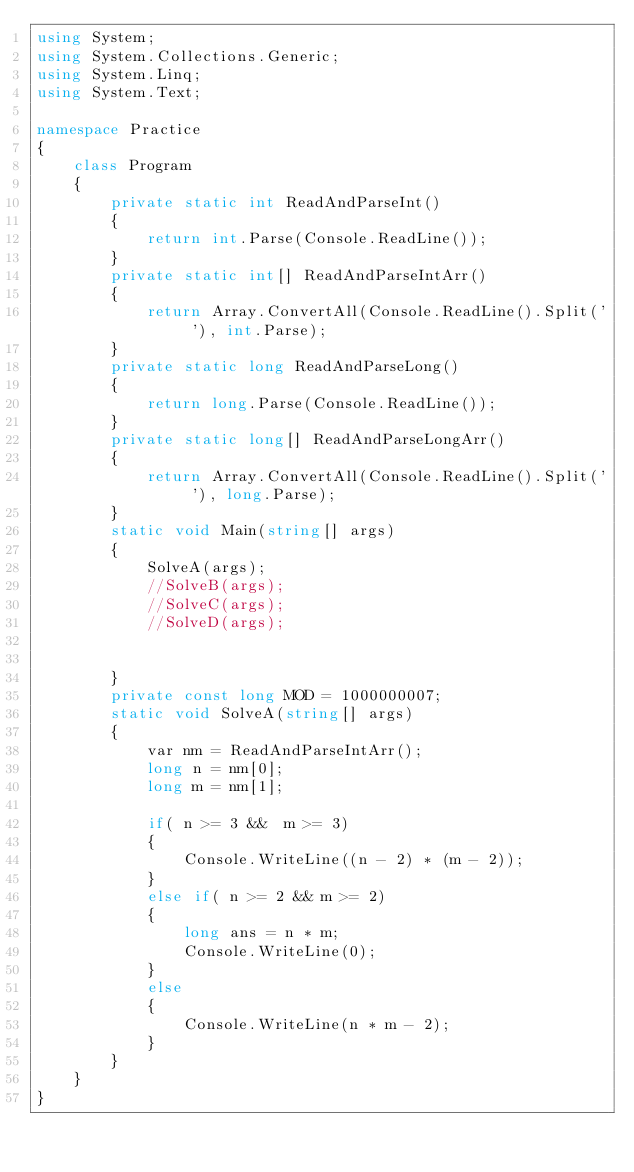<code> <loc_0><loc_0><loc_500><loc_500><_C#_>using System;
using System.Collections.Generic;
using System.Linq;
using System.Text;

namespace Practice
{
    class Program
    {
        private static int ReadAndParseInt()
        {
            return int.Parse(Console.ReadLine());
        }
        private static int[] ReadAndParseIntArr()
        {
            return Array.ConvertAll(Console.ReadLine().Split(' '), int.Parse);
        }
        private static long ReadAndParseLong()
        {
            return long.Parse(Console.ReadLine());
        }
        private static long[] ReadAndParseLongArr()
        {
            return Array.ConvertAll(Console.ReadLine().Split(' '), long.Parse);
        }
        static void Main(string[] args)
        {
            SolveA(args);
            //SolveB(args);
            //SolveC(args);
            //SolveD(args);


        }
        private const long MOD = 1000000007;
        static void SolveA(string[] args)
        {
            var nm = ReadAndParseIntArr();
            long n = nm[0];
            long m = nm[1];

            if( n >= 3 &&  m >= 3)
            {
                Console.WriteLine((n - 2) * (m - 2));
            }
            else if( n >= 2 && m >= 2)
            {
                long ans = n * m;
                Console.WriteLine(0);
            }
            else
            {
                Console.WriteLine(n * m - 2);
            }
        }
    }
}</code> 